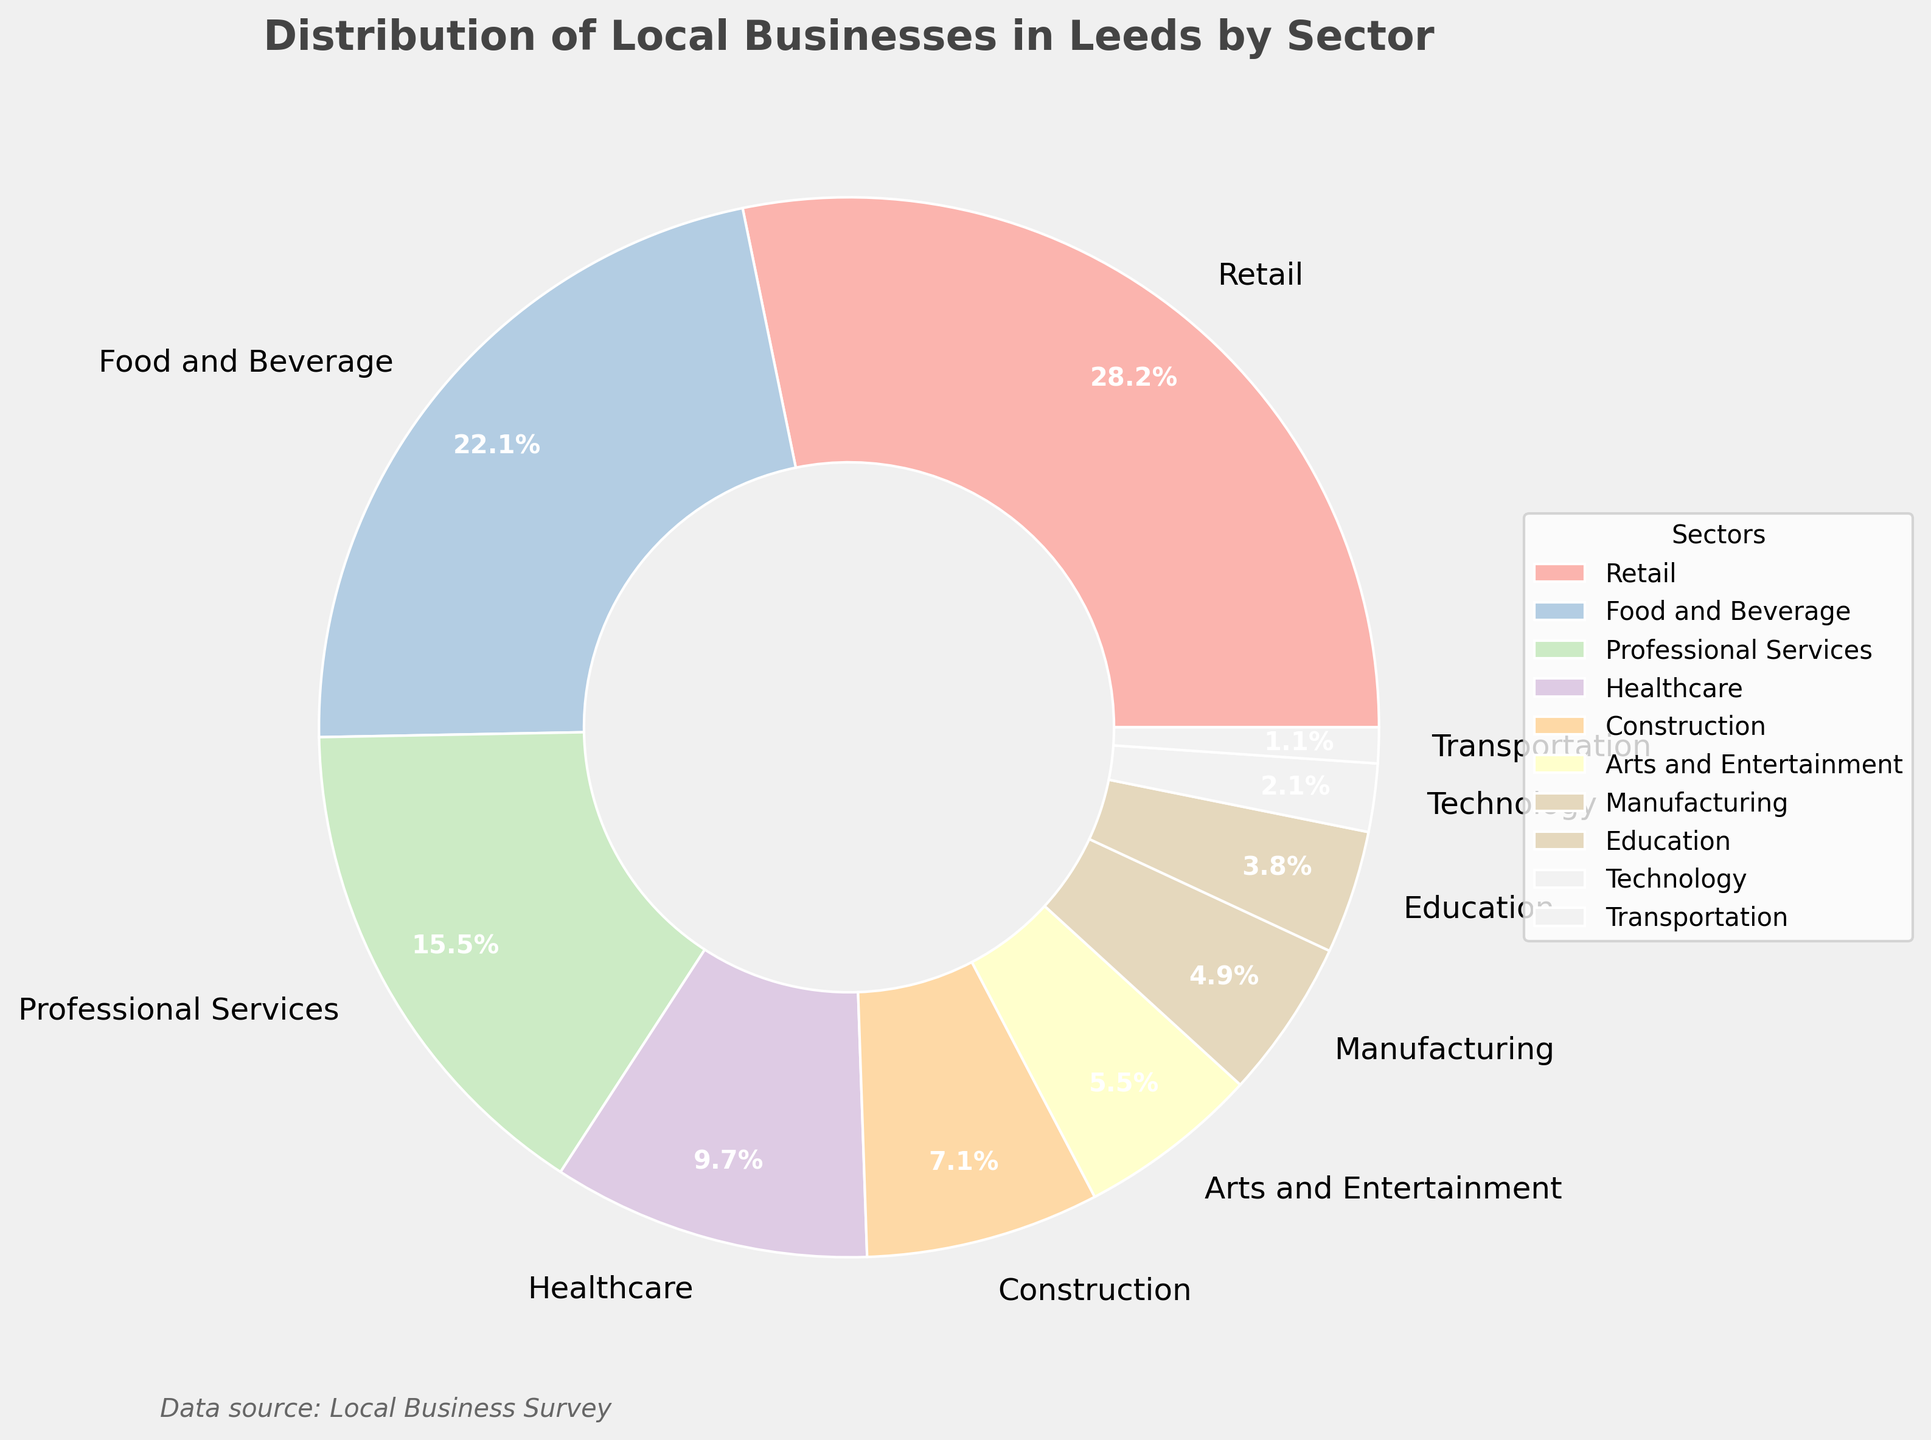What is the largest sector in terms of percentage? The largest sector can be found by looking at the slice of the pie chart that covers the largest area or by checking the legend corresponding to the highest percentage. The largest percentage shown is for Retail.
Answer: Retail What is the smallest sector represented in the pie chart? The smallest sector can be determined by finding the slice of the pie chart that covers the smallest area or the percentage that is the smallest in the legend. The smallest percentage listed is for Transportation.
Answer: Transportation What is the combined percentage of the Retail and Food and Beverage sectors? Add the percentages of the Retail and Food and Beverage sectors. Retail is 28.5% and Food and Beverage is 22.3%. So, 28.5 + 22.3 = 50.8%.
Answer: 50.8% How does the percentage of Healthcare compare to that of Professional Services? To compare the two sectors, note their percentages. Healthcare is 9.8% and Professional Services is 15.7%. Thus, Professional Services has a higher percentage than Healthcare.
Answer: Professional Services has a higher percentage What is the difference in percentage between the Manufacturing and Construction sectors? Subtract the percentage of the Manufacturing sector from the Construction sector. Construction is 7.2% and Manufacturing is 4.9%. So, 7.2 - 4.9 = 2.3%.
Answer: 2.3% Which sectors have percentages less than 5%? Sectors with percentages less than 5% can be identified by checking the legend. Manufacturing (4.9%), Education (3.8%), Technology (2.1%), and Transportation (1.1%) all fall below 5%.
Answer: Manufacturing, Education, Technology, Transportation What is the percentage difference between the highest and lowest represented sectors? Subtract the percentage of the smallest sector from that of the largest sector. The highest is Retail at 28.5%, and the lowest is Transportation at 1.1%. So, 28.5 - 1.1 = 27.4%.
Answer: 27.4% How many sectors have a percentage greater than 15%? Count the number of sectors with percentages greater than 15%. Only Retail (28.5%) and Food and Beverage (22.3%) meet this criterion.
Answer: 2 sectors What is the average percentage of the Technology and Arts and Entertainment sectors? Add the percentages of Technology and Arts and Entertainment, then divide by 2 for the average. Technology is 2.1% and Arts and Entertainment is 5.6%. The sum is 2.1 + 5.6 = 7.7%. So, the average is 7.7 / 2 = 3.85%.
Answer: 3.85% Which sector with a percentage over 20% has the second highest representation? Identify sectors with percentages over 20%. Retail (28.5%) and Food and Beverage (22.3%) qualify. The second highest percentage among these is Food and Beverage.
Answer: Food and Beverage 